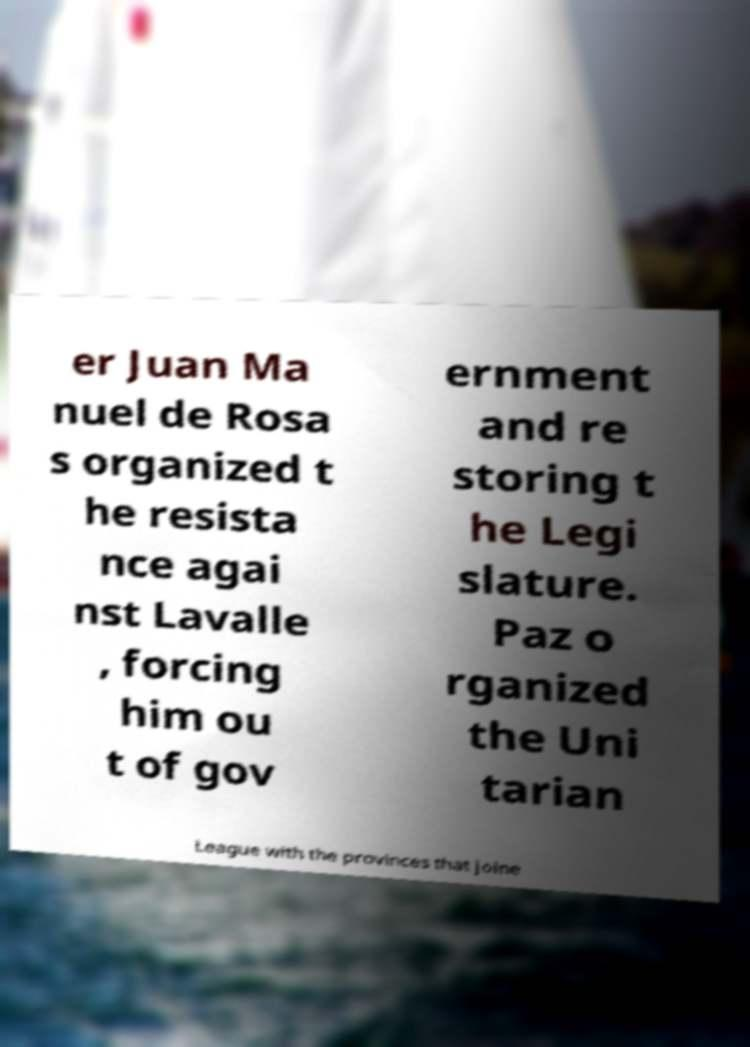For documentation purposes, I need the text within this image transcribed. Could you provide that? er Juan Ma nuel de Rosa s organized t he resista nce agai nst Lavalle , forcing him ou t of gov ernment and re storing t he Legi slature. Paz o rganized the Uni tarian League with the provinces that joine 